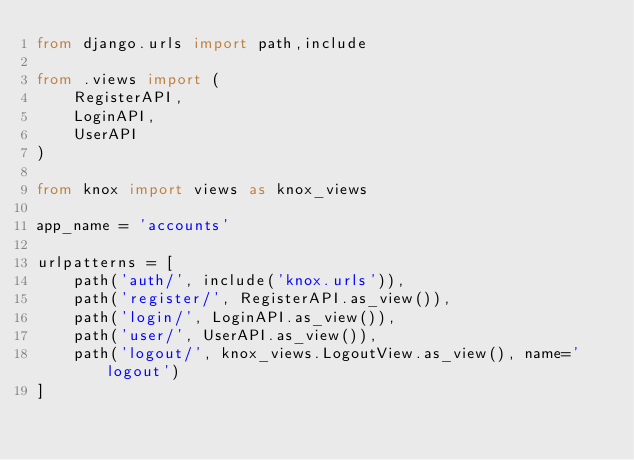Convert code to text. <code><loc_0><loc_0><loc_500><loc_500><_Python_>from django.urls import path,include

from .views import (
    RegisterAPI,
    LoginAPI,
    UserAPI
)

from knox import views as knox_views

app_name = 'accounts'

urlpatterns = [
    path('auth/', include('knox.urls')),
    path('register/', RegisterAPI.as_view()),
    path('login/', LoginAPI.as_view()),
    path('user/', UserAPI.as_view()),
    path('logout/', knox_views.LogoutView.as_view(), name='logout')
]
</code> 